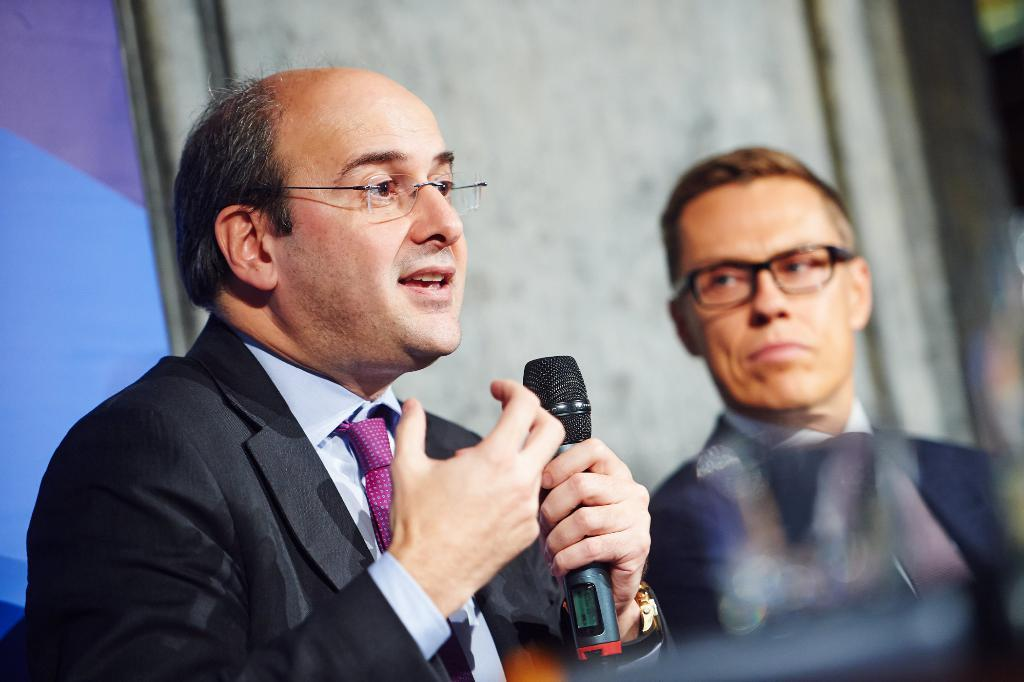How many people are in the image? There are two men in the image. What is one of the men holding in his hand? One of the men is holding a microphone in his hand. What type of note is the man holding in his hand? The man is not holding a note in his hand; he is holding a microphone. Can you see a cup in the image? There is no cup present in the image. 